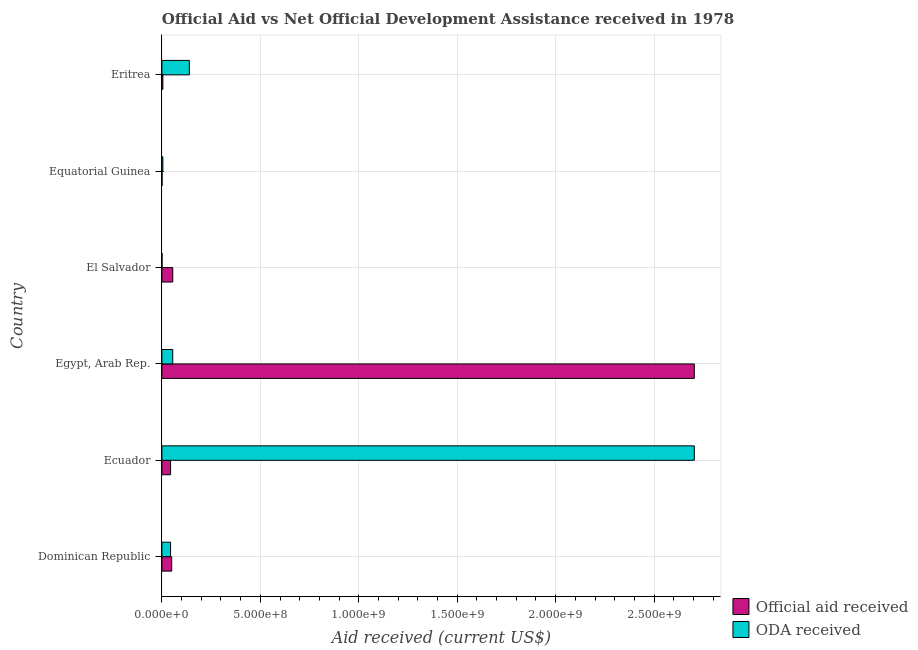Are the number of bars per tick equal to the number of legend labels?
Offer a terse response. Yes. How many bars are there on the 6th tick from the top?
Your answer should be very brief. 2. What is the label of the 2nd group of bars from the top?
Offer a terse response. Equatorial Guinea. What is the official aid received in Equatorial Guinea?
Provide a short and direct response. 5.90e+05. Across all countries, what is the maximum official aid received?
Give a very brief answer. 2.70e+09. Across all countries, what is the minimum official aid received?
Offer a terse response. 5.90e+05. In which country was the official aid received maximum?
Make the answer very short. Egypt, Arab Rep. In which country was the official aid received minimum?
Keep it short and to the point. Equatorial Guinea. What is the total official aid received in the graph?
Give a very brief answer. 2.86e+09. What is the difference between the oda received in Egypt, Arab Rep. and that in Eritrea?
Ensure brevity in your answer.  -8.42e+07. What is the average oda received per country?
Make the answer very short. 4.91e+08. What is the difference between the official aid received and oda received in Equatorial Guinea?
Your answer should be very brief. -4.34e+06. In how many countries, is the oda received greater than 1300000000 US$?
Provide a short and direct response. 1. What is the ratio of the oda received in Dominican Republic to that in Ecuador?
Your answer should be very brief. 0.02. What is the difference between the highest and the second highest official aid received?
Your answer should be very brief. 2.65e+09. What is the difference between the highest and the lowest oda received?
Provide a short and direct response. 2.70e+09. In how many countries, is the official aid received greater than the average official aid received taken over all countries?
Give a very brief answer. 1. What does the 1st bar from the top in Eritrea represents?
Offer a very short reply. ODA received. What does the 2nd bar from the bottom in El Salvador represents?
Your response must be concise. ODA received. How many countries are there in the graph?
Provide a succinct answer. 6. What is the difference between two consecutive major ticks on the X-axis?
Ensure brevity in your answer.  5.00e+08. Does the graph contain any zero values?
Your answer should be very brief. No. Does the graph contain grids?
Provide a succinct answer. Yes. Where does the legend appear in the graph?
Ensure brevity in your answer.  Bottom right. What is the title of the graph?
Your answer should be compact. Official Aid vs Net Official Development Assistance received in 1978 . What is the label or title of the X-axis?
Keep it short and to the point. Aid received (current US$). What is the label or title of the Y-axis?
Your response must be concise. Country. What is the Aid received (current US$) in Official aid received in Dominican Republic?
Your answer should be compact. 4.98e+07. What is the Aid received (current US$) of ODA received in Dominican Republic?
Your response must be concise. 4.40e+07. What is the Aid received (current US$) in Official aid received in Ecuador?
Offer a terse response. 4.40e+07. What is the Aid received (current US$) of ODA received in Ecuador?
Your response must be concise. 2.70e+09. What is the Aid received (current US$) of Official aid received in Egypt, Arab Rep.?
Keep it short and to the point. 2.70e+09. What is the Aid received (current US$) of ODA received in Egypt, Arab Rep.?
Keep it short and to the point. 5.51e+07. What is the Aid received (current US$) of Official aid received in El Salvador?
Your response must be concise. 5.51e+07. What is the Aid received (current US$) of ODA received in El Salvador?
Offer a very short reply. 5.90e+05. What is the Aid received (current US$) of Official aid received in Equatorial Guinea?
Offer a terse response. 5.90e+05. What is the Aid received (current US$) in ODA received in Equatorial Guinea?
Give a very brief answer. 4.93e+06. What is the Aid received (current US$) of Official aid received in Eritrea?
Your answer should be compact. 4.93e+06. What is the Aid received (current US$) of ODA received in Eritrea?
Offer a terse response. 1.39e+08. Across all countries, what is the maximum Aid received (current US$) of Official aid received?
Your response must be concise. 2.70e+09. Across all countries, what is the maximum Aid received (current US$) in ODA received?
Provide a short and direct response. 2.70e+09. Across all countries, what is the minimum Aid received (current US$) in Official aid received?
Your answer should be compact. 5.90e+05. Across all countries, what is the minimum Aid received (current US$) of ODA received?
Your answer should be very brief. 5.90e+05. What is the total Aid received (current US$) in Official aid received in the graph?
Ensure brevity in your answer.  2.86e+09. What is the total Aid received (current US$) of ODA received in the graph?
Make the answer very short. 2.95e+09. What is the difference between the Aid received (current US$) in Official aid received in Dominican Republic and that in Ecuador?
Provide a succinct answer. 5.80e+06. What is the difference between the Aid received (current US$) of ODA received in Dominican Republic and that in Ecuador?
Keep it short and to the point. -2.66e+09. What is the difference between the Aid received (current US$) of Official aid received in Dominican Republic and that in Egypt, Arab Rep.?
Ensure brevity in your answer.  -2.65e+09. What is the difference between the Aid received (current US$) of ODA received in Dominican Republic and that in Egypt, Arab Rep.?
Offer a very short reply. -1.11e+07. What is the difference between the Aid received (current US$) of Official aid received in Dominican Republic and that in El Salvador?
Keep it short and to the point. -5.33e+06. What is the difference between the Aid received (current US$) of ODA received in Dominican Republic and that in El Salvador?
Offer a very short reply. 4.34e+07. What is the difference between the Aid received (current US$) of Official aid received in Dominican Republic and that in Equatorial Guinea?
Make the answer very short. 4.92e+07. What is the difference between the Aid received (current US$) of ODA received in Dominican Republic and that in Equatorial Guinea?
Offer a terse response. 3.91e+07. What is the difference between the Aid received (current US$) of Official aid received in Dominican Republic and that in Eritrea?
Your answer should be very brief. 4.49e+07. What is the difference between the Aid received (current US$) of ODA received in Dominican Republic and that in Eritrea?
Offer a very short reply. -9.53e+07. What is the difference between the Aid received (current US$) of Official aid received in Ecuador and that in Egypt, Arab Rep.?
Offer a very short reply. -2.66e+09. What is the difference between the Aid received (current US$) in ODA received in Ecuador and that in Egypt, Arab Rep.?
Provide a short and direct response. 2.65e+09. What is the difference between the Aid received (current US$) in Official aid received in Ecuador and that in El Salvador?
Offer a terse response. -1.11e+07. What is the difference between the Aid received (current US$) in ODA received in Ecuador and that in El Salvador?
Your response must be concise. 2.70e+09. What is the difference between the Aid received (current US$) in Official aid received in Ecuador and that in Equatorial Guinea?
Ensure brevity in your answer.  4.34e+07. What is the difference between the Aid received (current US$) of ODA received in Ecuador and that in Equatorial Guinea?
Your response must be concise. 2.70e+09. What is the difference between the Aid received (current US$) of Official aid received in Ecuador and that in Eritrea?
Your answer should be compact. 3.91e+07. What is the difference between the Aid received (current US$) of ODA received in Ecuador and that in Eritrea?
Provide a short and direct response. 2.56e+09. What is the difference between the Aid received (current US$) in Official aid received in Egypt, Arab Rep. and that in El Salvador?
Ensure brevity in your answer.  2.65e+09. What is the difference between the Aid received (current US$) in ODA received in Egypt, Arab Rep. and that in El Salvador?
Make the answer very short. 5.45e+07. What is the difference between the Aid received (current US$) in Official aid received in Egypt, Arab Rep. and that in Equatorial Guinea?
Your answer should be compact. 2.70e+09. What is the difference between the Aid received (current US$) in ODA received in Egypt, Arab Rep. and that in Equatorial Guinea?
Offer a terse response. 5.02e+07. What is the difference between the Aid received (current US$) of Official aid received in Egypt, Arab Rep. and that in Eritrea?
Provide a short and direct response. 2.70e+09. What is the difference between the Aid received (current US$) in ODA received in Egypt, Arab Rep. and that in Eritrea?
Provide a short and direct response. -8.42e+07. What is the difference between the Aid received (current US$) of Official aid received in El Salvador and that in Equatorial Guinea?
Provide a short and direct response. 5.45e+07. What is the difference between the Aid received (current US$) in ODA received in El Salvador and that in Equatorial Guinea?
Keep it short and to the point. -4.34e+06. What is the difference between the Aid received (current US$) of Official aid received in El Salvador and that in Eritrea?
Offer a very short reply. 5.02e+07. What is the difference between the Aid received (current US$) of ODA received in El Salvador and that in Eritrea?
Keep it short and to the point. -1.39e+08. What is the difference between the Aid received (current US$) in Official aid received in Equatorial Guinea and that in Eritrea?
Make the answer very short. -4.34e+06. What is the difference between the Aid received (current US$) in ODA received in Equatorial Guinea and that in Eritrea?
Make the answer very short. -1.34e+08. What is the difference between the Aid received (current US$) of Official aid received in Dominican Republic and the Aid received (current US$) of ODA received in Ecuador?
Offer a very short reply. -2.65e+09. What is the difference between the Aid received (current US$) of Official aid received in Dominican Republic and the Aid received (current US$) of ODA received in Egypt, Arab Rep.?
Your answer should be compact. -5.33e+06. What is the difference between the Aid received (current US$) in Official aid received in Dominican Republic and the Aid received (current US$) in ODA received in El Salvador?
Ensure brevity in your answer.  4.92e+07. What is the difference between the Aid received (current US$) of Official aid received in Dominican Republic and the Aid received (current US$) of ODA received in Equatorial Guinea?
Keep it short and to the point. 4.49e+07. What is the difference between the Aid received (current US$) of Official aid received in Dominican Republic and the Aid received (current US$) of ODA received in Eritrea?
Make the answer very short. -8.95e+07. What is the difference between the Aid received (current US$) in Official aid received in Ecuador and the Aid received (current US$) in ODA received in Egypt, Arab Rep.?
Offer a terse response. -1.11e+07. What is the difference between the Aid received (current US$) in Official aid received in Ecuador and the Aid received (current US$) in ODA received in El Salvador?
Give a very brief answer. 4.34e+07. What is the difference between the Aid received (current US$) of Official aid received in Ecuador and the Aid received (current US$) of ODA received in Equatorial Guinea?
Provide a short and direct response. 3.91e+07. What is the difference between the Aid received (current US$) in Official aid received in Ecuador and the Aid received (current US$) in ODA received in Eritrea?
Offer a very short reply. -9.53e+07. What is the difference between the Aid received (current US$) of Official aid received in Egypt, Arab Rep. and the Aid received (current US$) of ODA received in El Salvador?
Provide a short and direct response. 2.70e+09. What is the difference between the Aid received (current US$) of Official aid received in Egypt, Arab Rep. and the Aid received (current US$) of ODA received in Equatorial Guinea?
Keep it short and to the point. 2.70e+09. What is the difference between the Aid received (current US$) in Official aid received in Egypt, Arab Rep. and the Aid received (current US$) in ODA received in Eritrea?
Offer a terse response. 2.56e+09. What is the difference between the Aid received (current US$) in Official aid received in El Salvador and the Aid received (current US$) in ODA received in Equatorial Guinea?
Provide a succinct answer. 5.02e+07. What is the difference between the Aid received (current US$) in Official aid received in El Salvador and the Aid received (current US$) in ODA received in Eritrea?
Make the answer very short. -8.42e+07. What is the difference between the Aid received (current US$) of Official aid received in Equatorial Guinea and the Aid received (current US$) of ODA received in Eritrea?
Keep it short and to the point. -1.39e+08. What is the average Aid received (current US$) in Official aid received per country?
Provide a short and direct response. 4.76e+08. What is the average Aid received (current US$) in ODA received per country?
Make the answer very short. 4.91e+08. What is the difference between the Aid received (current US$) of Official aid received and Aid received (current US$) of ODA received in Dominican Republic?
Keep it short and to the point. 5.80e+06. What is the difference between the Aid received (current US$) of Official aid received and Aid received (current US$) of ODA received in Ecuador?
Your answer should be very brief. -2.66e+09. What is the difference between the Aid received (current US$) of Official aid received and Aid received (current US$) of ODA received in Egypt, Arab Rep.?
Provide a short and direct response. 2.65e+09. What is the difference between the Aid received (current US$) in Official aid received and Aid received (current US$) in ODA received in El Salvador?
Ensure brevity in your answer.  5.45e+07. What is the difference between the Aid received (current US$) of Official aid received and Aid received (current US$) of ODA received in Equatorial Guinea?
Your answer should be very brief. -4.34e+06. What is the difference between the Aid received (current US$) in Official aid received and Aid received (current US$) in ODA received in Eritrea?
Offer a terse response. -1.34e+08. What is the ratio of the Aid received (current US$) of Official aid received in Dominican Republic to that in Ecuador?
Your answer should be very brief. 1.13. What is the ratio of the Aid received (current US$) of ODA received in Dominican Republic to that in Ecuador?
Offer a terse response. 0.02. What is the ratio of the Aid received (current US$) of Official aid received in Dominican Republic to that in Egypt, Arab Rep.?
Give a very brief answer. 0.02. What is the ratio of the Aid received (current US$) in ODA received in Dominican Republic to that in Egypt, Arab Rep.?
Your response must be concise. 0.8. What is the ratio of the Aid received (current US$) in Official aid received in Dominican Republic to that in El Salvador?
Keep it short and to the point. 0.9. What is the ratio of the Aid received (current US$) in ODA received in Dominican Republic to that in El Salvador?
Offer a terse response. 74.58. What is the ratio of the Aid received (current US$) of Official aid received in Dominican Republic to that in Equatorial Guinea?
Provide a short and direct response. 84.41. What is the ratio of the Aid received (current US$) of ODA received in Dominican Republic to that in Equatorial Guinea?
Your answer should be compact. 8.92. What is the ratio of the Aid received (current US$) of Official aid received in Dominican Republic to that in Eritrea?
Keep it short and to the point. 10.1. What is the ratio of the Aid received (current US$) in ODA received in Dominican Republic to that in Eritrea?
Provide a short and direct response. 0.32. What is the ratio of the Aid received (current US$) in Official aid received in Ecuador to that in Egypt, Arab Rep.?
Ensure brevity in your answer.  0.02. What is the ratio of the Aid received (current US$) in ODA received in Ecuador to that in Egypt, Arab Rep.?
Provide a short and direct response. 49.05. What is the ratio of the Aid received (current US$) of Official aid received in Ecuador to that in El Salvador?
Offer a very short reply. 0.8. What is the ratio of the Aid received (current US$) of ODA received in Ecuador to that in El Salvador?
Ensure brevity in your answer.  4583.54. What is the ratio of the Aid received (current US$) in Official aid received in Ecuador to that in Equatorial Guinea?
Provide a short and direct response. 74.58. What is the ratio of the Aid received (current US$) in ODA received in Ecuador to that in Equatorial Guinea?
Give a very brief answer. 548.54. What is the ratio of the Aid received (current US$) in Official aid received in Ecuador to that in Eritrea?
Ensure brevity in your answer.  8.92. What is the ratio of the Aid received (current US$) of ODA received in Ecuador to that in Eritrea?
Offer a very short reply. 19.41. What is the ratio of the Aid received (current US$) in Official aid received in Egypt, Arab Rep. to that in El Salvador?
Make the answer very short. 49.05. What is the ratio of the Aid received (current US$) of ODA received in Egypt, Arab Rep. to that in El Salvador?
Keep it short and to the point. 93.44. What is the ratio of the Aid received (current US$) in Official aid received in Egypt, Arab Rep. to that in Equatorial Guinea?
Your answer should be very brief. 4583.54. What is the ratio of the Aid received (current US$) in ODA received in Egypt, Arab Rep. to that in Equatorial Guinea?
Give a very brief answer. 11.18. What is the ratio of the Aid received (current US$) in Official aid received in Egypt, Arab Rep. to that in Eritrea?
Ensure brevity in your answer.  548.54. What is the ratio of the Aid received (current US$) of ODA received in Egypt, Arab Rep. to that in Eritrea?
Offer a terse response. 0.4. What is the ratio of the Aid received (current US$) of Official aid received in El Salvador to that in Equatorial Guinea?
Your answer should be compact. 93.44. What is the ratio of the Aid received (current US$) of ODA received in El Salvador to that in Equatorial Guinea?
Keep it short and to the point. 0.12. What is the ratio of the Aid received (current US$) of Official aid received in El Salvador to that in Eritrea?
Provide a short and direct response. 11.18. What is the ratio of the Aid received (current US$) of ODA received in El Salvador to that in Eritrea?
Offer a very short reply. 0. What is the ratio of the Aid received (current US$) of Official aid received in Equatorial Guinea to that in Eritrea?
Make the answer very short. 0.12. What is the ratio of the Aid received (current US$) of ODA received in Equatorial Guinea to that in Eritrea?
Give a very brief answer. 0.04. What is the difference between the highest and the second highest Aid received (current US$) of Official aid received?
Offer a very short reply. 2.65e+09. What is the difference between the highest and the second highest Aid received (current US$) in ODA received?
Make the answer very short. 2.56e+09. What is the difference between the highest and the lowest Aid received (current US$) of Official aid received?
Your answer should be compact. 2.70e+09. What is the difference between the highest and the lowest Aid received (current US$) in ODA received?
Keep it short and to the point. 2.70e+09. 